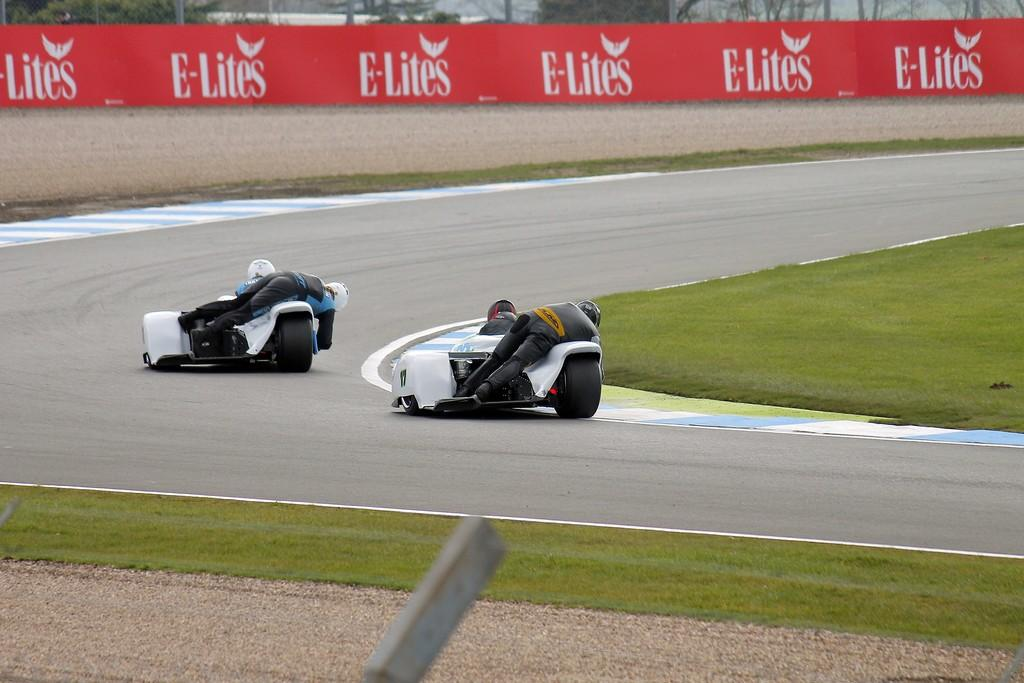How many vehicles are present in the image? There are two vehicles in the image. What are the persons on the vehicles doing? The persons on the vehicles are wearing black color dress. What can be seen in the background of the image? There is a wall and a board in the background of the image. What colors are the wall and the board? The wall is in cream color, and the board is in red color. Where is the goat sitting and eating lunch in the image? There is no goat or lunchroom present in the image. What type of glass can be seen on the vehicles in the image? There is no glass visible on the vehicles in the image. 